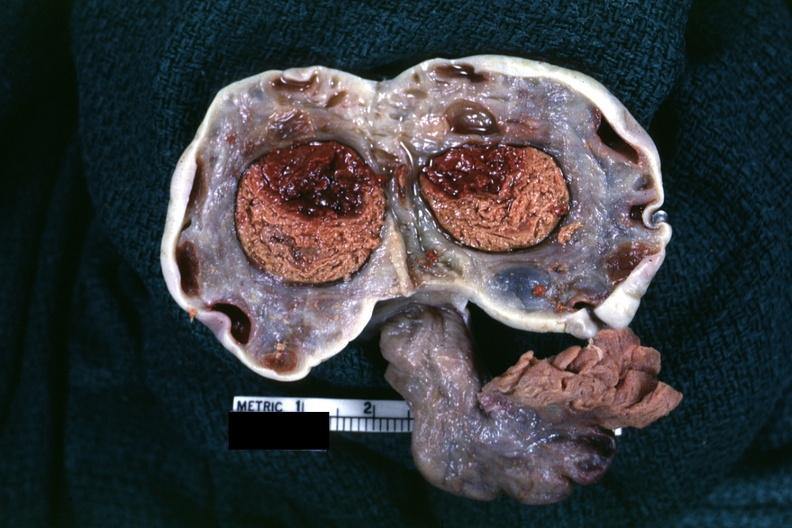where does this belong to?
Answer the question using a single word or phrase. Female reproductive system 